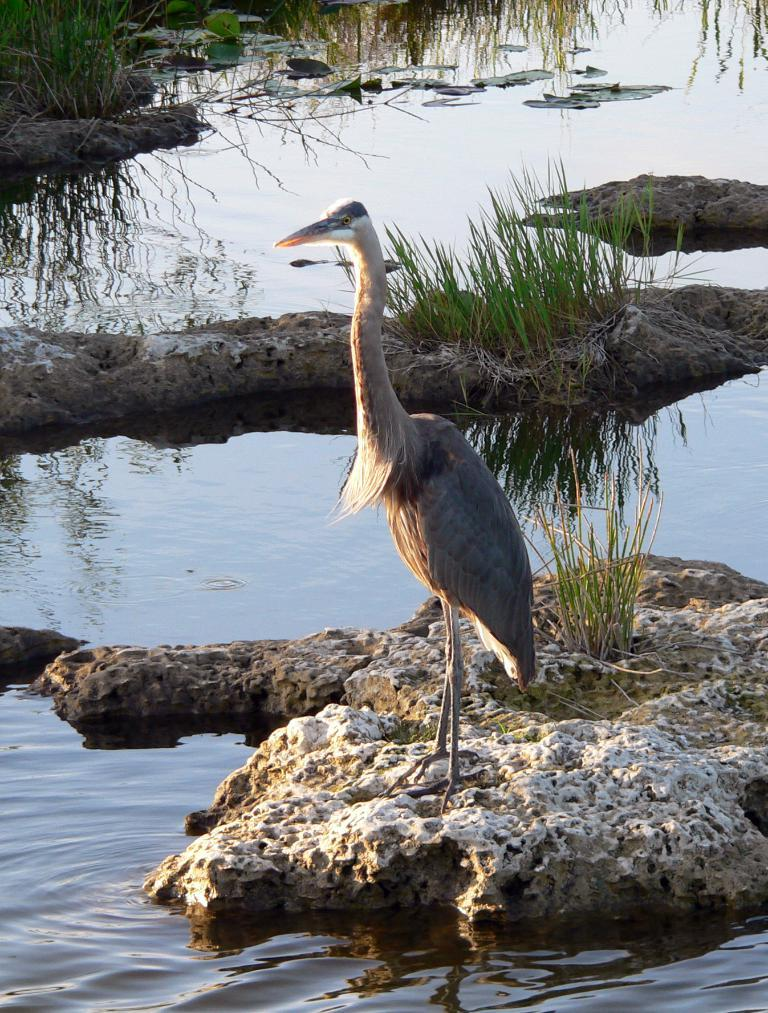What type of animal is in the image? There is a bird in the image. Where is the bird located? The bird is on a stone. What can be seen at the bottom of the image? There is water at the bottom of the image. What type of vegetation is visible in the background? There is grass in the background of the image. What type of punishment is the bird receiving in the image? There is no indication of punishment in the image; the bird is simply perched on a stone. How does the bird show respect to the stone in the image? The bird does not show respect to the stone in the image; it is simply sitting on it. 